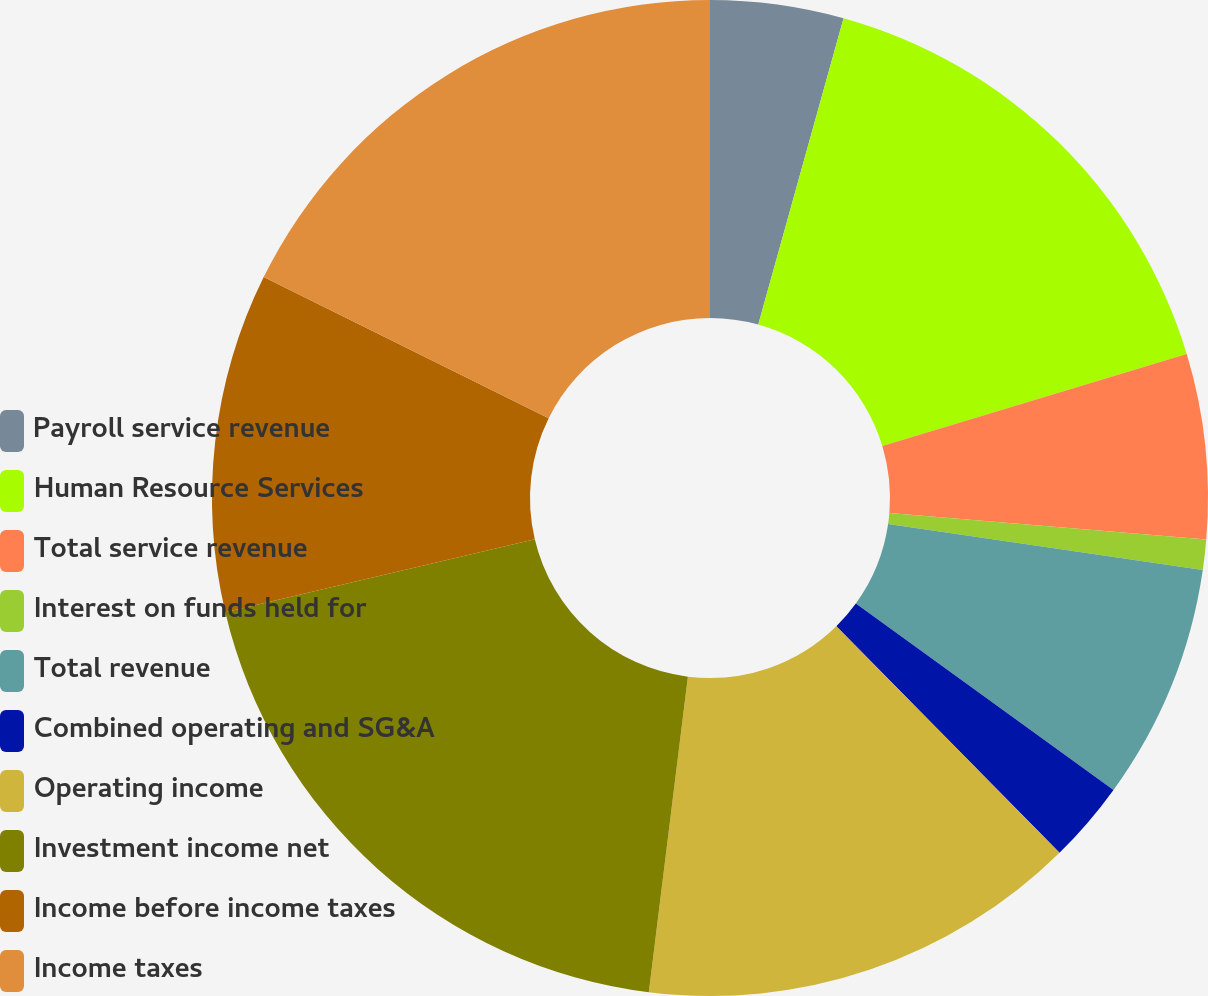<chart> <loc_0><loc_0><loc_500><loc_500><pie_chart><fcel>Payroll service revenue<fcel>Human Resource Services<fcel>Total service revenue<fcel>Interest on funds held for<fcel>Total revenue<fcel>Combined operating and SG&A<fcel>Operating income<fcel>Investment income net<fcel>Income before income taxes<fcel>Income taxes<nl><fcel>4.32%<fcel>16.01%<fcel>5.99%<fcel>0.98%<fcel>7.66%<fcel>2.65%<fcel>14.34%<fcel>19.35%<fcel>11.0%<fcel>17.68%<nl></chart> 